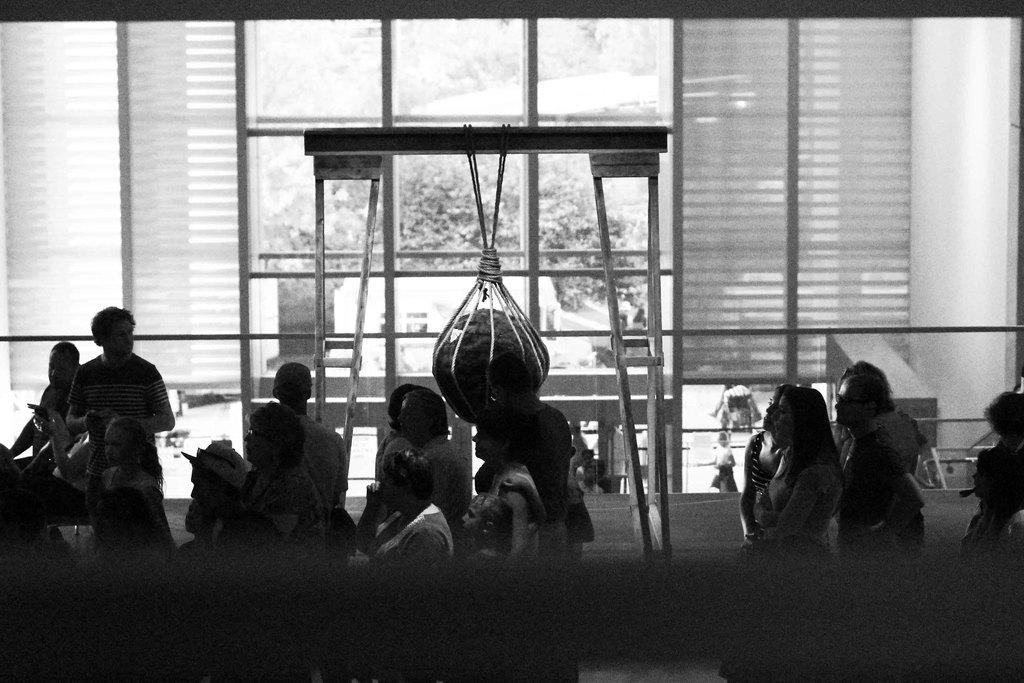What can be seen in the image? There are people standing in the image. What is visible in the background of the image? There are trees visible in the background of the image. What is the color scheme of the image? The image is black and white in color. Can you hear the person whistling in the image? There is no sound in the image, so it is not possible to hear anyone whistling. 